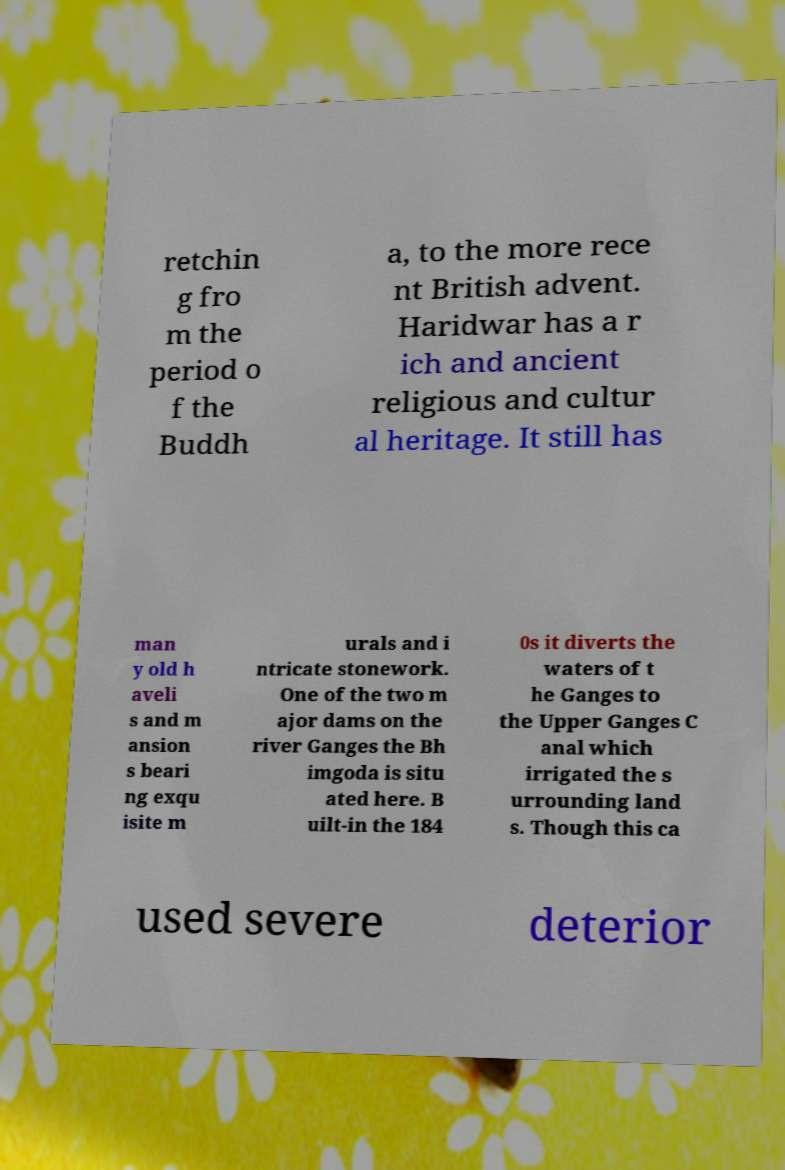I need the written content from this picture converted into text. Can you do that? retchin g fro m the period o f the Buddh a, to the more rece nt British advent. Haridwar has a r ich and ancient religious and cultur al heritage. It still has man y old h aveli s and m ansion s beari ng exqu isite m urals and i ntricate stonework. One of the two m ajor dams on the river Ganges the Bh imgoda is situ ated here. B uilt-in the 184 0s it diverts the waters of t he Ganges to the Upper Ganges C anal which irrigated the s urrounding land s. Though this ca used severe deterior 